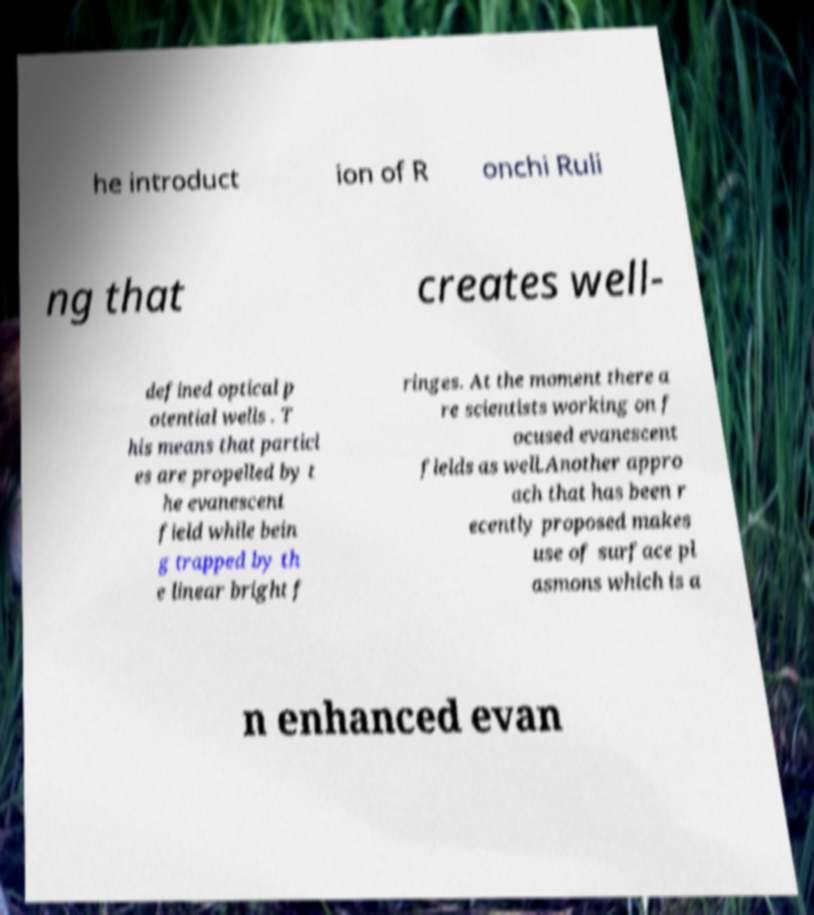Can you read and provide the text displayed in the image?This photo seems to have some interesting text. Can you extract and type it out for me? he introduct ion of R onchi Ruli ng that creates well- defined optical p otential wells . T his means that particl es are propelled by t he evanescent field while bein g trapped by th e linear bright f ringes. At the moment there a re scientists working on f ocused evanescent fields as well.Another appro ach that has been r ecently proposed makes use of surface pl asmons which is a n enhanced evan 